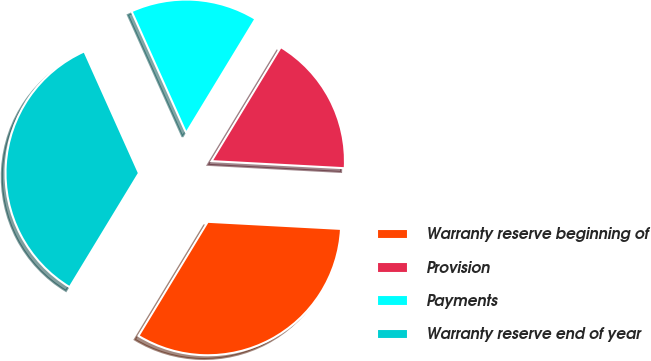Convert chart to OTSL. <chart><loc_0><loc_0><loc_500><loc_500><pie_chart><fcel>Warranty reserve beginning of<fcel>Provision<fcel>Payments<fcel>Warranty reserve end of year<nl><fcel>32.84%<fcel>17.16%<fcel>15.4%<fcel>34.6%<nl></chart> 